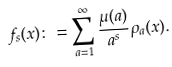Convert formula to latex. <formula><loc_0><loc_0><loc_500><loc_500>f _ { s } ( x ) \colon = \sum _ { a = 1 } ^ { \infty } \frac { \mu ( a ) } { a ^ { s } } \rho _ { a } ( x ) .</formula> 